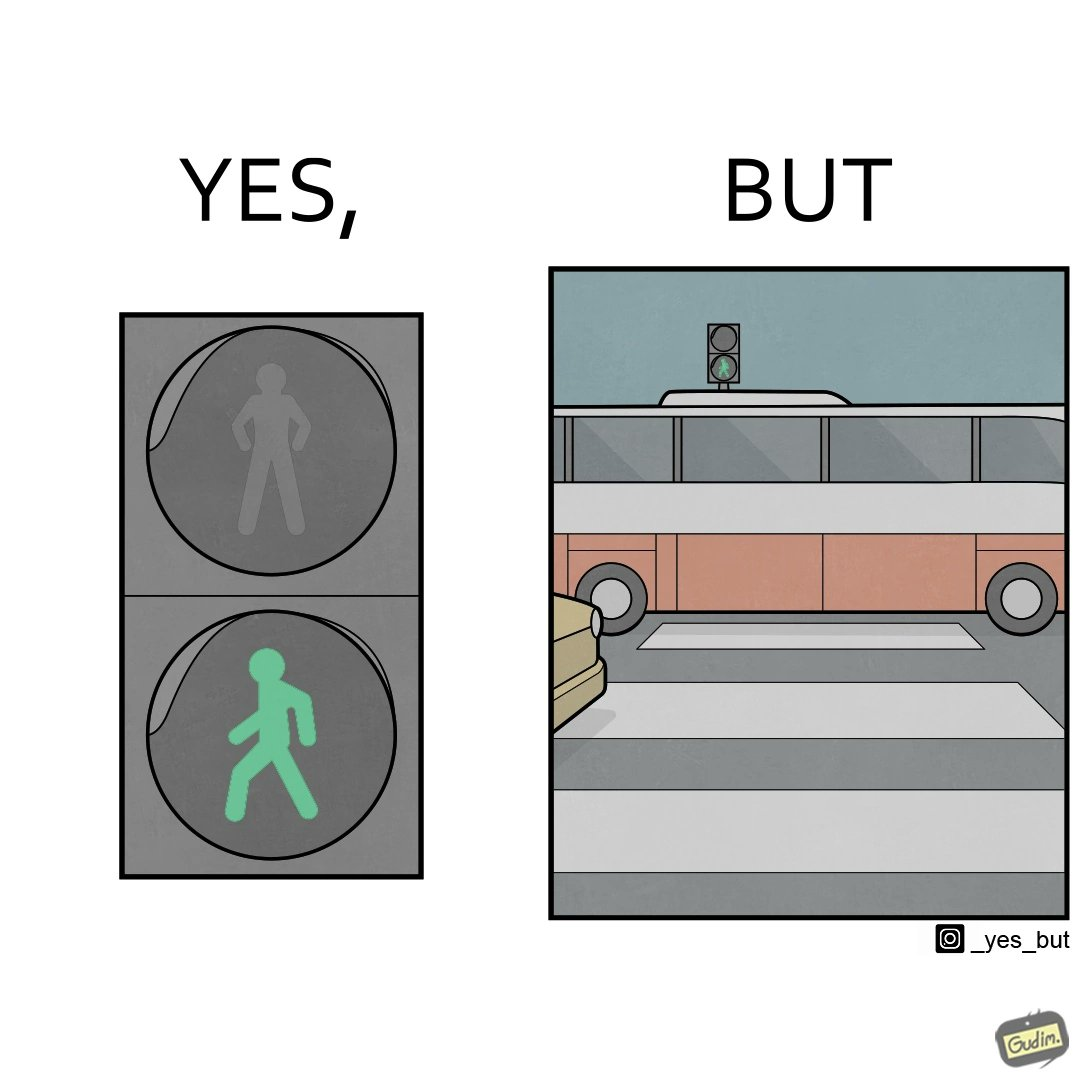Would you classify this image as satirical? Yes, this image is satirical. 